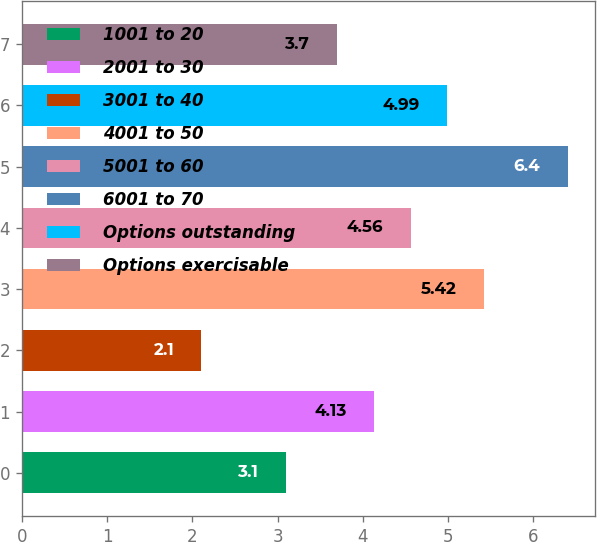Convert chart. <chart><loc_0><loc_0><loc_500><loc_500><bar_chart><fcel>1001 to 20<fcel>2001 to 30<fcel>3001 to 40<fcel>4001 to 50<fcel>5001 to 60<fcel>6001 to 70<fcel>Options outstanding<fcel>Options exercisable<nl><fcel>3.1<fcel>4.13<fcel>2.1<fcel>5.42<fcel>4.56<fcel>6.4<fcel>4.99<fcel>3.7<nl></chart> 